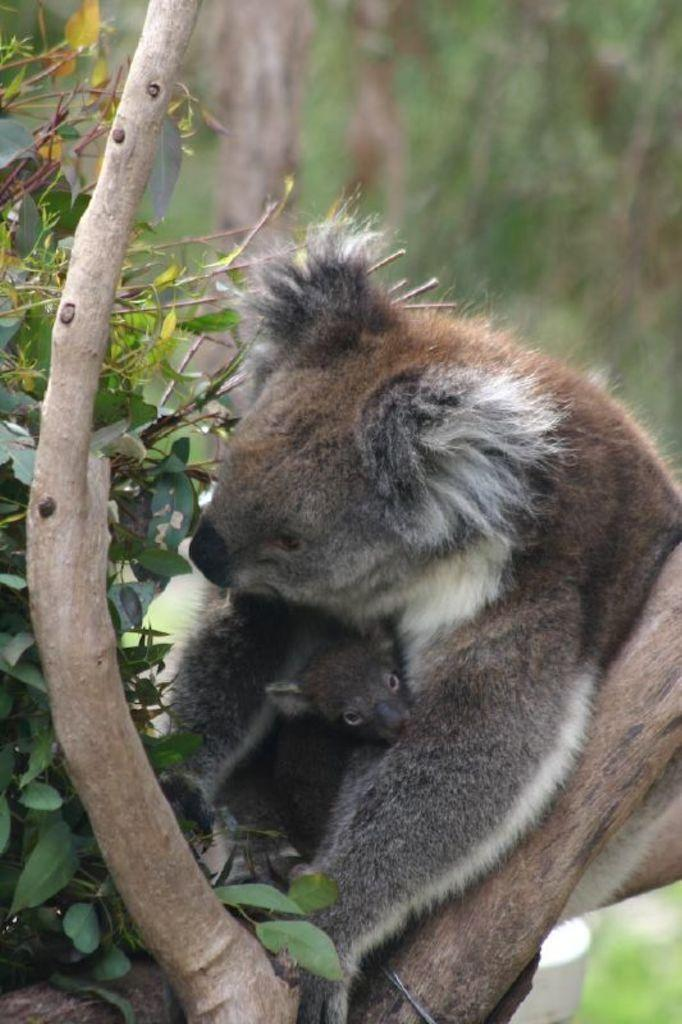What is the main subject of the image? There is an animal on a tree in the image. Can you describe the background of the image? The background of the image is blurred. Reasoning: Let'g: Let's think step by step in order to produce the conversation. We start by identifying the main subject of the image, which is the animal on the tree. Then, we describe the background of the image, noting that it is blurred. We avoid yes/no questions and ensure that the language is simple and clear. Absurd Question/Answer: What type of stem can be seen in the image? There is no stem present in the image; it features an animal on a tree and a blurred background. What type of view can be seen from the animal's perspective in the image? There is no indication of the animal's perspective in the image, as it only shows the animal on a tree and a blurred background. --- Facts: 1. There is a person holding a book in the image. 2. The person is sitting on a chair. 3. The book has a blue cover. 4. There is a table next to the chair. 5. The table has a lamp on it. Absurd Topics: ocean, dance, guitar Conversation: What is the person in the image holding? The person is holding a book in the image. What is the person's position in the image? The person is sitting on a chair. What color is the book's cover? The book has a blue cover. What is located next to the chair in the image? There is a table next to the chair in the image. What object is on the table? The table has a lamp on it. Reasoning: Let's think step by step in order to produce the conversation. We start by identifying the main subject of the image, which is the person holding a book. Then, we describe the person's position and the color of the book's cover. Next, we mention the presence of a table and a lamp 